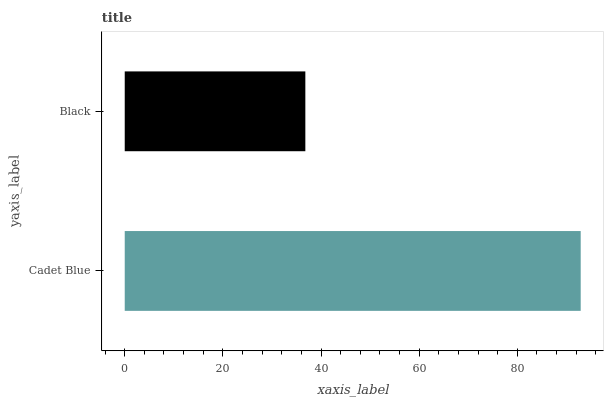Is Black the minimum?
Answer yes or no. Yes. Is Cadet Blue the maximum?
Answer yes or no. Yes. Is Black the maximum?
Answer yes or no. No. Is Cadet Blue greater than Black?
Answer yes or no. Yes. Is Black less than Cadet Blue?
Answer yes or no. Yes. Is Black greater than Cadet Blue?
Answer yes or no. No. Is Cadet Blue less than Black?
Answer yes or no. No. Is Cadet Blue the high median?
Answer yes or no. Yes. Is Black the low median?
Answer yes or no. Yes. Is Black the high median?
Answer yes or no. No. Is Cadet Blue the low median?
Answer yes or no. No. 